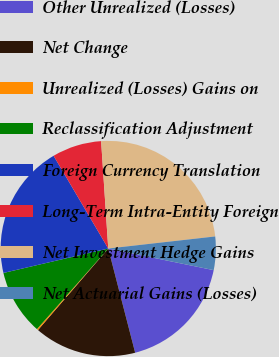<chart> <loc_0><loc_0><loc_500><loc_500><pie_chart><fcel>Other Unrealized (Losses)<fcel>Net Change<fcel>Unrealized (Losses) Gains on<fcel>Reclassification Adjustment<fcel>Foreign Currency Translation<fcel>Long-Term Intra-Entity Foreign<fcel>Net Investment Hedge Gains<fcel>Net Actuarial Gains (Losses)<nl><fcel>17.76%<fcel>15.35%<fcel>0.2%<fcel>9.83%<fcel>20.17%<fcel>7.42%<fcel>24.27%<fcel>5.01%<nl></chart> 